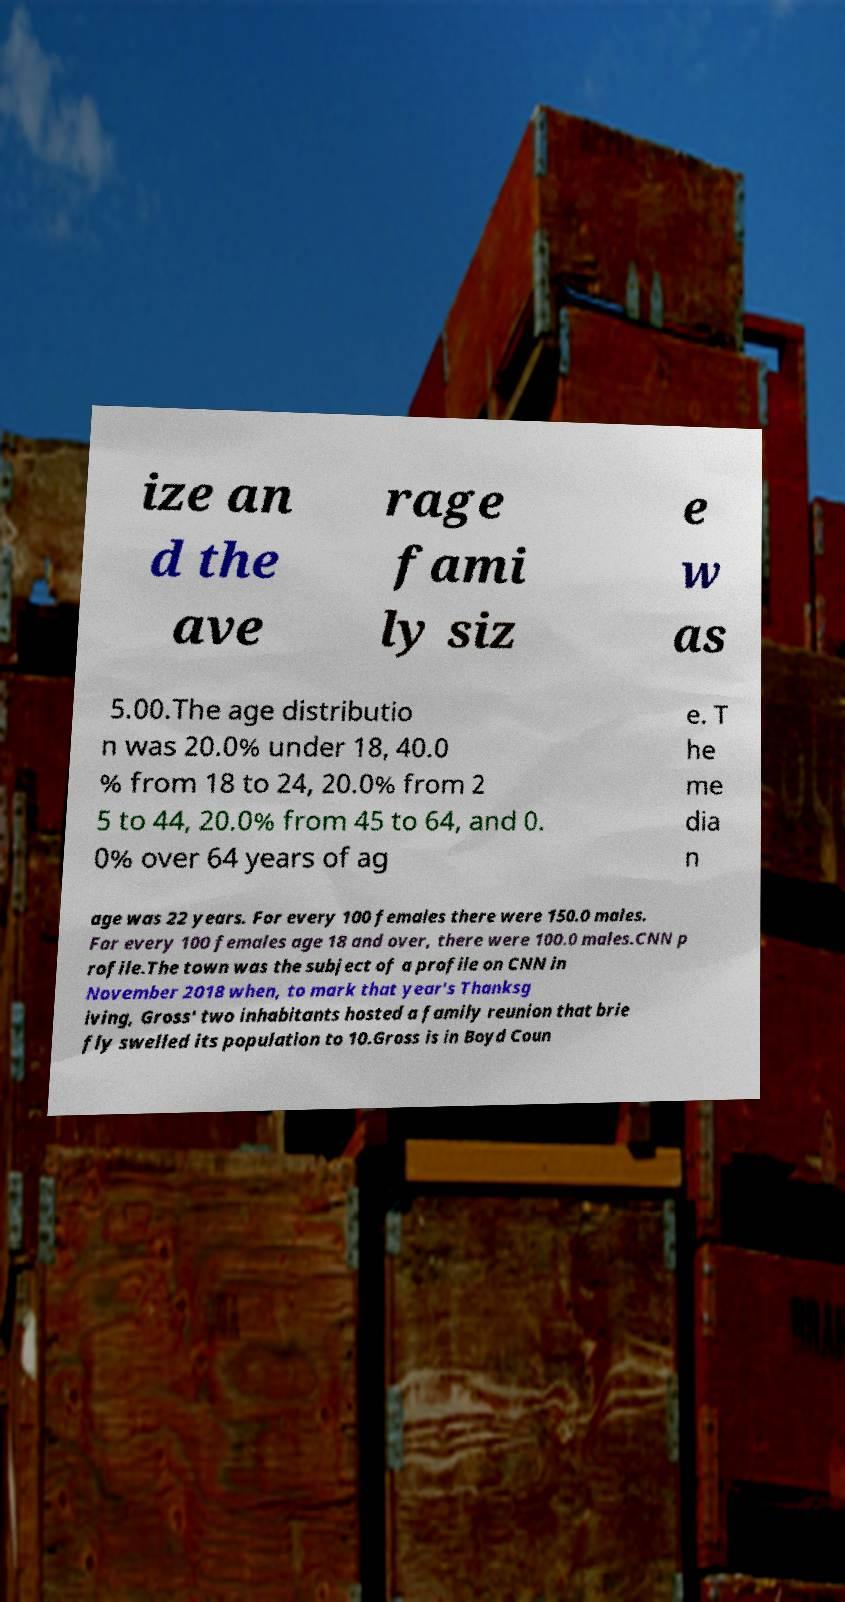Please read and relay the text visible in this image. What does it say? ize an d the ave rage fami ly siz e w as 5.00.The age distributio n was 20.0% under 18, 40.0 % from 18 to 24, 20.0% from 2 5 to 44, 20.0% from 45 to 64, and 0. 0% over 64 years of ag e. T he me dia n age was 22 years. For every 100 females there were 150.0 males. For every 100 females age 18 and over, there were 100.0 males.CNN p rofile.The town was the subject of a profile on CNN in November 2018 when, to mark that year's Thanksg iving, Gross' two inhabitants hosted a family reunion that brie fly swelled its population to 10.Gross is in Boyd Coun 